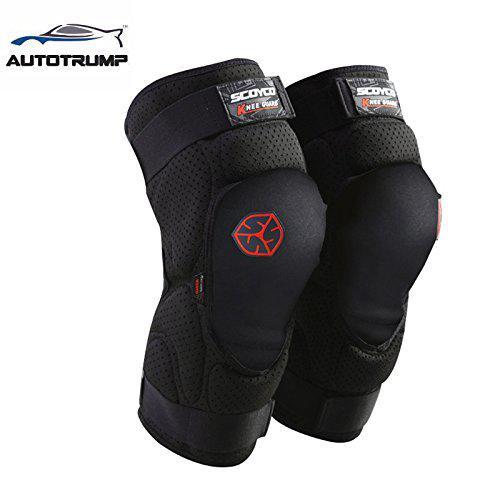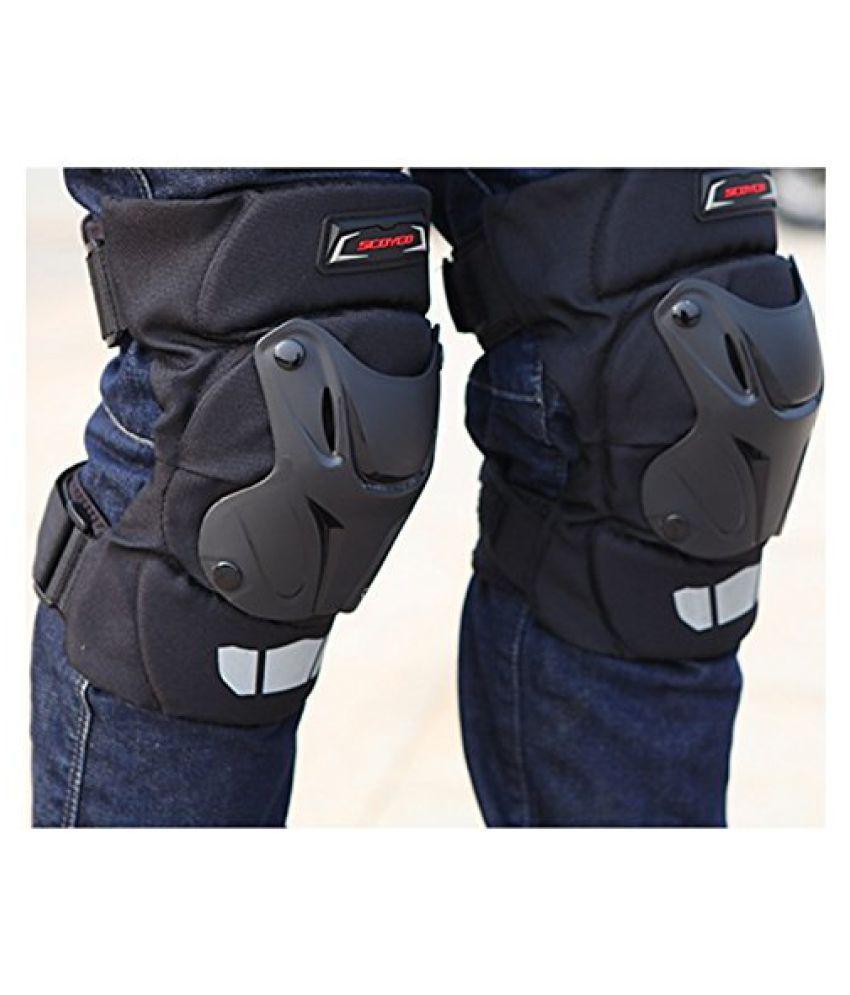The first image is the image on the left, the second image is the image on the right. For the images shown, is this caption "One image shows someone wearing at least one of the knee pads." true? Answer yes or no. Yes. The first image is the image on the left, the second image is the image on the right. Assess this claim about the two images: "At least one of the images has a human model wearing the item.". Correct or not? Answer yes or no. Yes. 